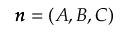<formula> <loc_0><loc_0><loc_500><loc_500>\pm b { n } = ( A , B , C )</formula> 